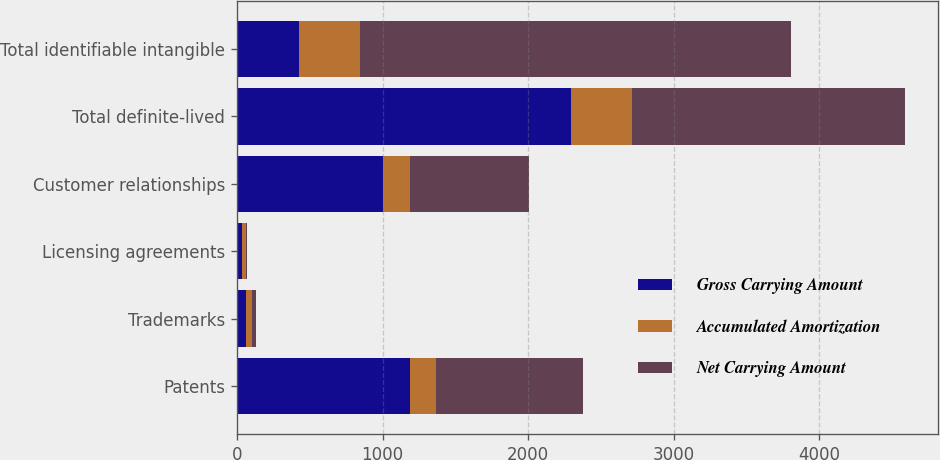<chart> <loc_0><loc_0><loc_500><loc_500><stacked_bar_chart><ecel><fcel>Patents<fcel>Trademarks<fcel>Licensing agreements<fcel>Customer relationships<fcel>Total definite-lived<fcel>Total identifiable intangible<nl><fcel>Gross Carrying Amount<fcel>1189.5<fcel>65.3<fcel>33.5<fcel>1004.8<fcel>2293.1<fcel>423.9<nl><fcel>Accumulated Amortization<fcel>177.3<fcel>38.7<fcel>26.7<fcel>181.2<fcel>423.9<fcel>423.9<nl><fcel>Net Carrying Amount<fcel>1012.2<fcel>26.6<fcel>6.8<fcel>823.6<fcel>1869.2<fcel>2957.6<nl></chart> 